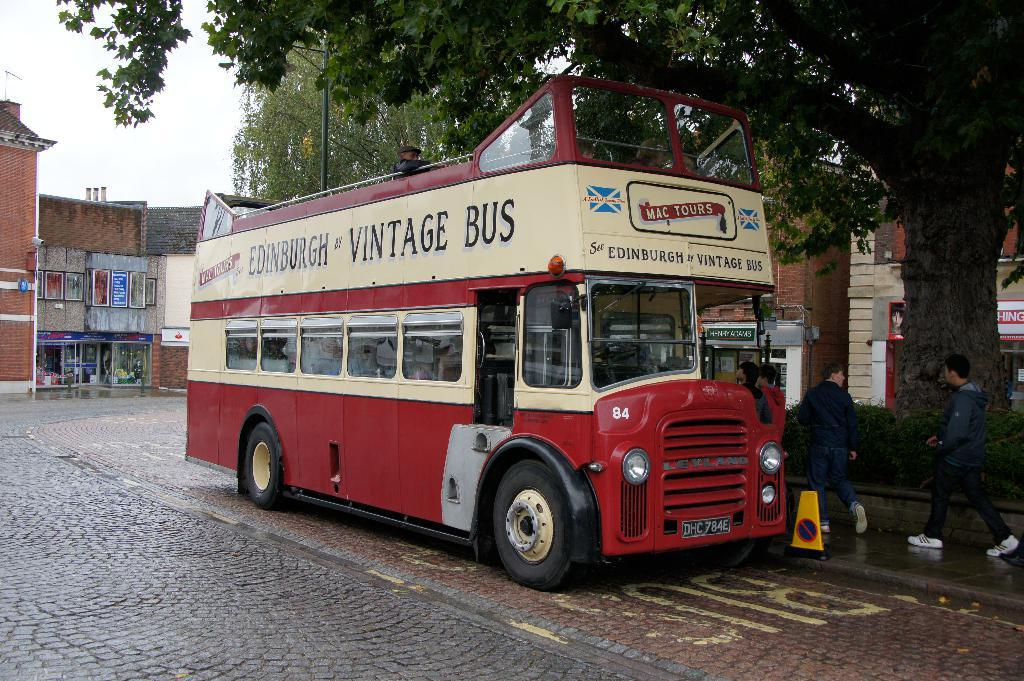<image>
Provide a brief description of the given image. a bus that has vintage bus written on it 